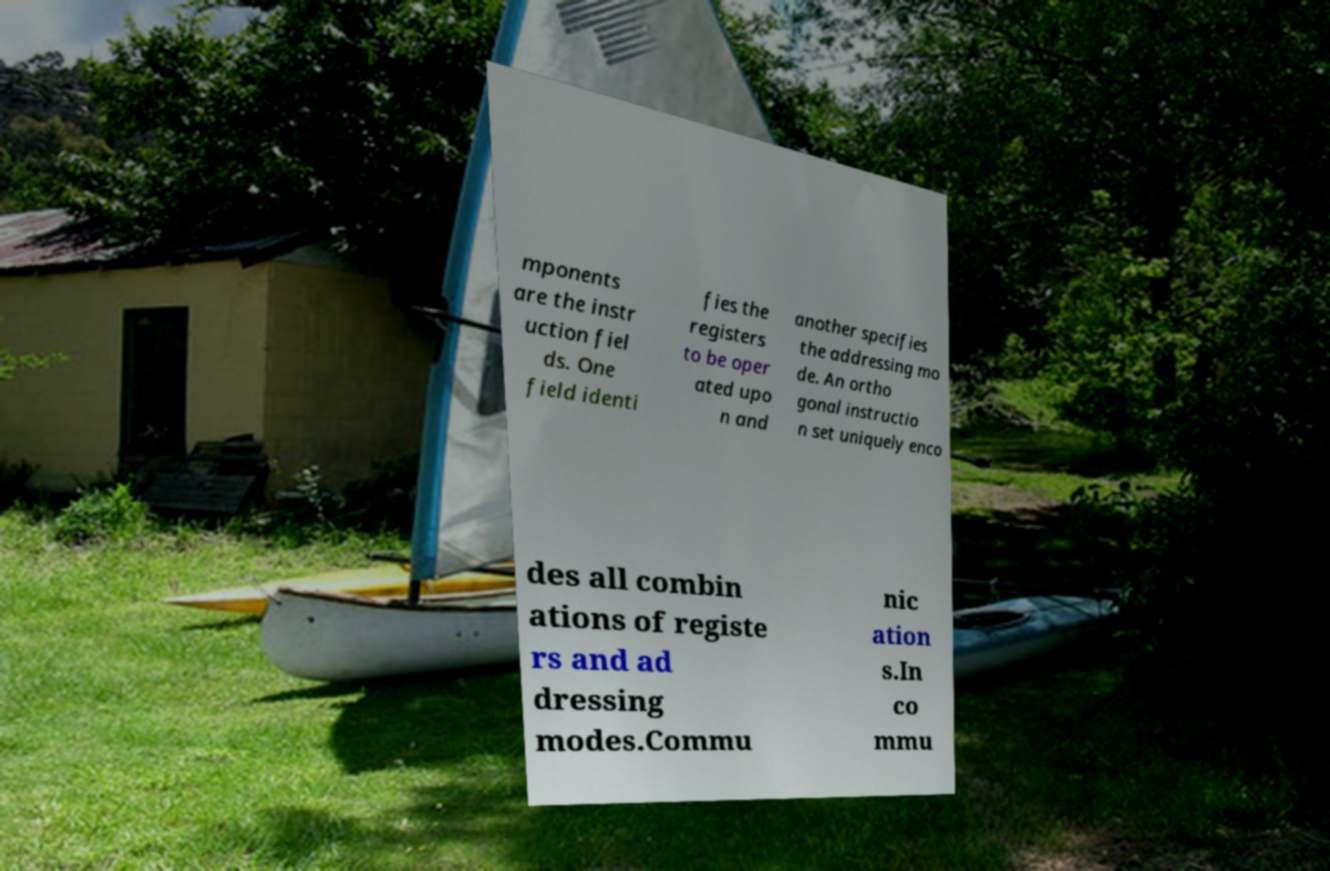For documentation purposes, I need the text within this image transcribed. Could you provide that? mponents are the instr uction fiel ds. One field identi fies the registers to be oper ated upo n and another specifies the addressing mo de. An ortho gonal instructio n set uniquely enco des all combin ations of registe rs and ad dressing modes.Commu nic ation s.In co mmu 